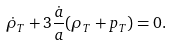Convert formula to latex. <formula><loc_0><loc_0><loc_500><loc_500>\dot { \rho } _ { T } + 3 \frac { \dot { a } } { a } ( \rho _ { T } + p _ { T } ) = 0 .</formula> 